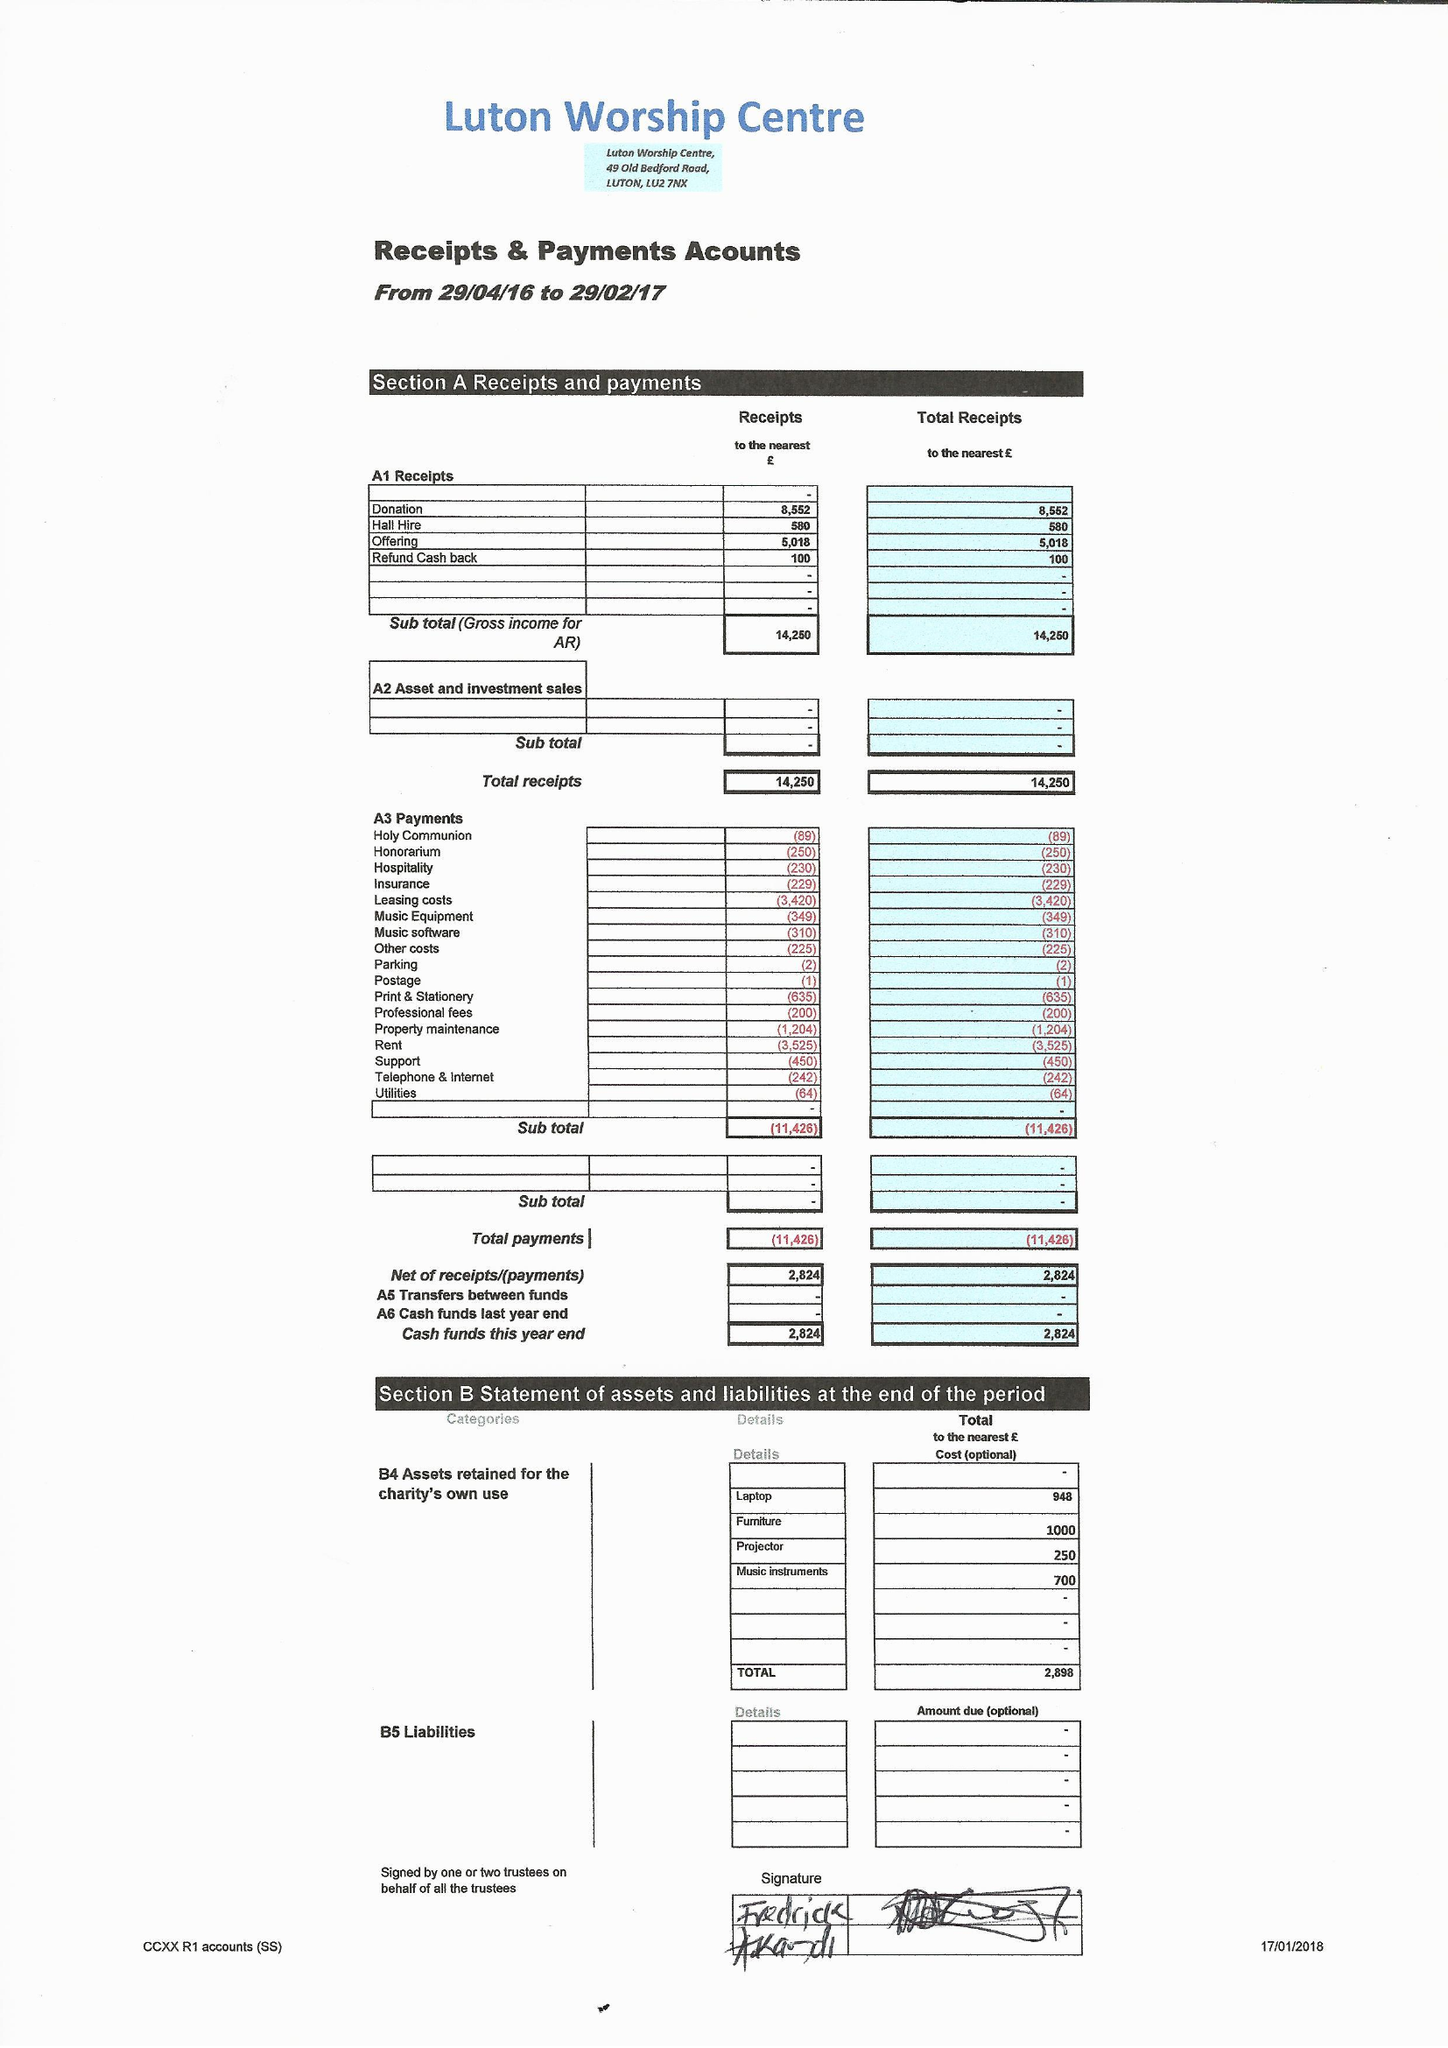What is the value for the income_annually_in_british_pounds?
Answer the question using a single word or phrase. 14250.00 